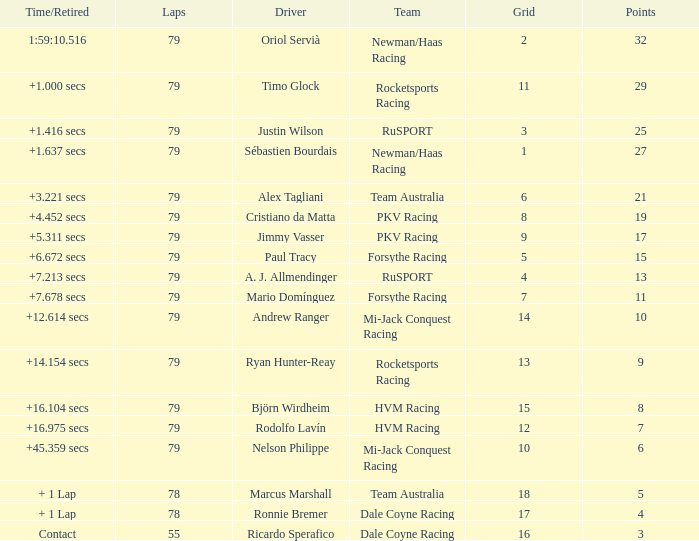Which points has the driver Paul Tracy? 15.0. 